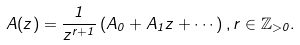<formula> <loc_0><loc_0><loc_500><loc_500>A ( z ) = \frac { 1 } { z ^ { r + 1 } } \left ( A _ { 0 } + A _ { 1 } z + \cdots \right ) , r \in \mathbb { Z } _ { > 0 } .</formula> 